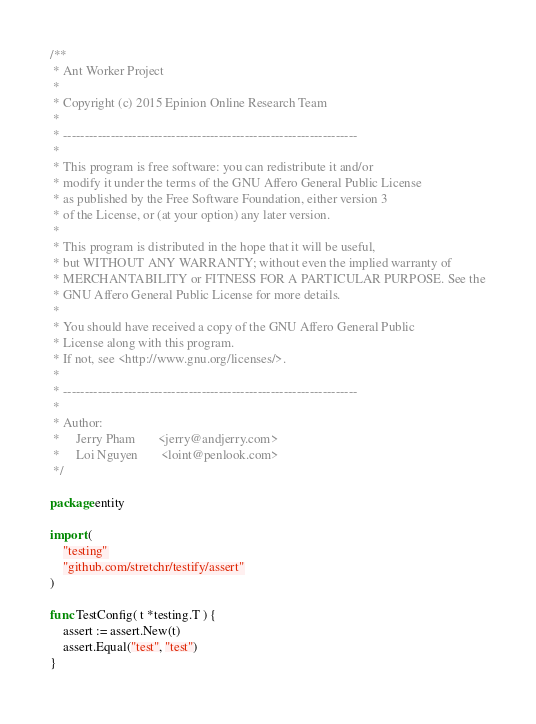<code> <loc_0><loc_0><loc_500><loc_500><_Go_>/**
 * Ant Worker Project
 *
 * Copyright (c) 2015 Epinion Online Research Team
 *
 * --------------------------------------------------------------------
 *
 * This program is free software: you can redistribute it and/or
 * modify it under the terms of the GNU Affero General Public License
 * as published by the Free Software Foundation, either version 3
 * of the License, or (at your option) any later version.
 *
 * This program is distributed in the hope that it will be useful,
 * but WITHOUT ANY WARRANTY; without even the implied warranty of
 * MERCHANTABILITY or FITNESS FOR A PARTICULAR PURPOSE. See the
 * GNU Affero General Public License for more details.
 *
 * You should have received a copy of the GNU Affero General Public
 * License along with this program.
 * If not, see <http://www.gnu.org/licenses/>.
 *
 * --------------------------------------------------------------------
 *
 * Author:
 *     Jerry Pham       <jerry@andjerry.com>
 *     Loi Nguyen       <loint@penlook.com>
 */

package entity

import (
	"testing"
	"github.com/stretchr/testify/assert"
)

func TestConfig( t *testing.T ) {
	assert := assert.New(t)
	assert.Equal("test", "test")
}

</code> 